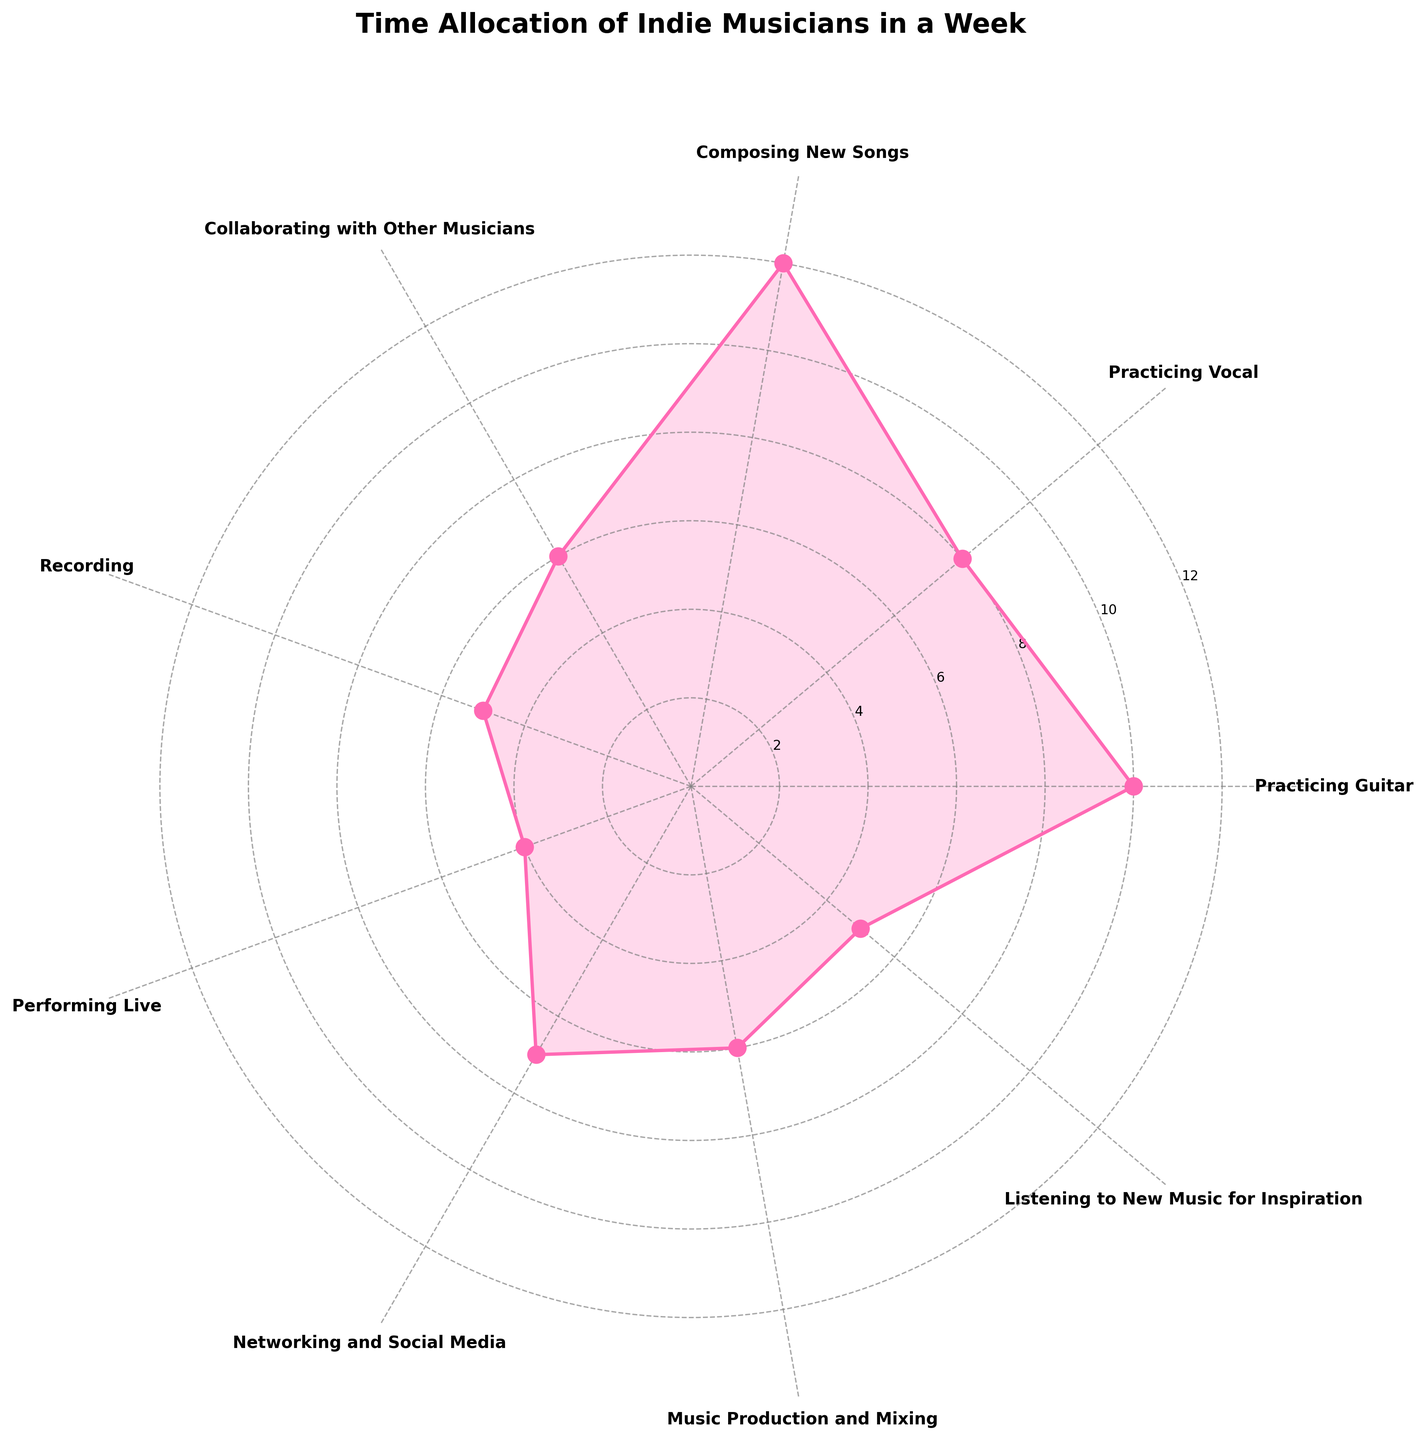What's the title of the chart? The title of the chart is displayed at the top and provides a summary of what the chart represents. By looking at the top of the figure, we see the title "Time Allocation of Indie Musicians in a Week."
Answer: Time Allocation of Indie Musicians in a Week What activity takes the most hours? By examining the length of each segment on the chart, we identify the segment that extends furthest from the center. The segment for "Composing New Songs" is the longest, meaning it takes the most hours.
Answer: Composing New Songs How many hours are spent practicing guitar and vocal combined? To find the total time spent on practicing, we need to sum the hours of "Practicing Guitar" (10 hours) and "Practicing Vocal" (8 hours). Thus, 10 + 8 = 18 hours.
Answer: 18 hours Which activity takes less time: Recording or Performing Live? By comparing the segments for "Recording" and "Performing Live," it is evident that the segment for "Performing Live" is shorter. Therefore, Performing Live takes less time than Recording.
Answer: Performing Live What is the average time spent on Networking and Social Media, Collaborating with Other Musicians, and Music Production and Mixing? To find the average, we sum the hours for these three activities: Networking and Social Media (7 hours), Collaborating with Other Musicians (6 hours), and Music Production and Mixing (6 hours). Thus, (7 + 6 + 6) / 3 = 6.33 hours.
Answer: 6.33 hours How does the time spent listening to new music for inspiration compare to recording? By comparing the lengths of the segments, we see that both activities have segments of equal length indicating the same time allocation, which is 5 hours each.
Answer: Equal What’s the total number of hours spent on all activities? To calculate the total, we add up the hours for each activity. The activities are Practicing Guitar (10), Practicing Vocal (8), Composing New Songs (12), Collaborating with Other Musicians (6), Recording (5), Performing Live (4), Networking and Social Media (7), Music Production and Mixing (6), Listening to New Music for Inspiration (5). Thus, 10 + 8 + 12 + 6 + 5 + 4 + 7 + 6 + 5 = 63 hours.
Answer: 63 hours Which activities have an equal amount of time allocated to them? By closely studying the chart, we identify that both "Recording" and "Listening to New Music for Inspiration" segments are of the same length indicating 5 hours each. Additionally, "Collaborating with Other Musicians" and "Music Production and Mixing" also have equal segments of 6 hours each.
Answer: Recording and Listening to New Music for Inspiration; Collaborating with Other Musicians and Music Production and Mixing How much more time is spent on composing new songs compared to performing live? To find this difference, we subtract the hours spent on "Performing Live" (4 hours) from the hours spent on "Composing New Songs" (12 hours). Therefore, 12 - 4 = 8 hours.
Answer: 8 hours What percentage of the total time is spent on practicing guitar? First, we find the total time spent on all activities, which is 63 hours. The time spent on "Practicing Guitar" is 10 hours. To find the percentage, we compute (10 / 63) * 100 ≈ 15.87%.
Answer: 15.87% 